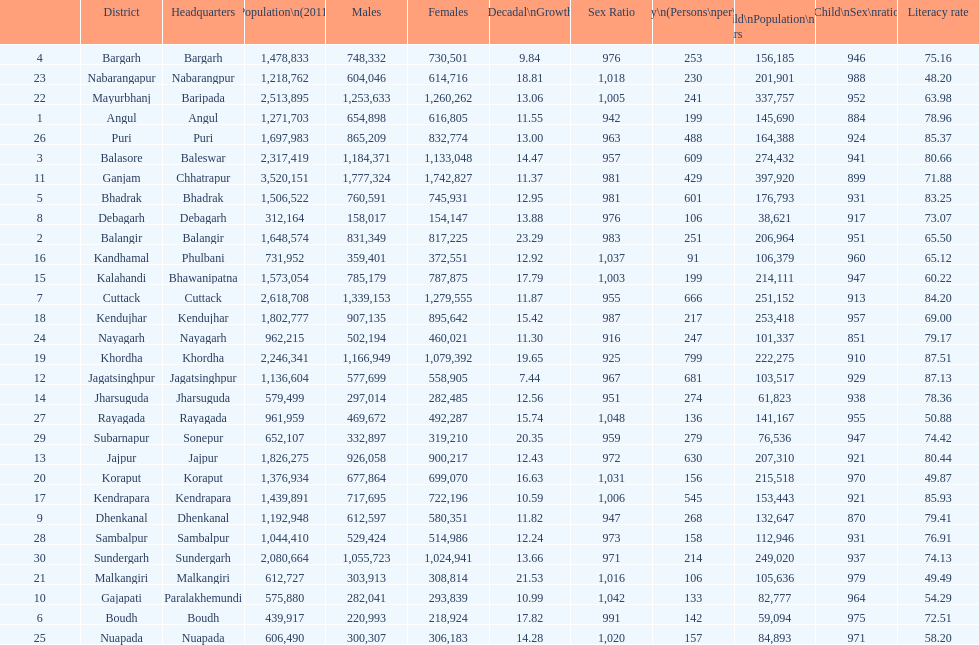In which city is the literacy rate the lowest? Nabarangapur. 